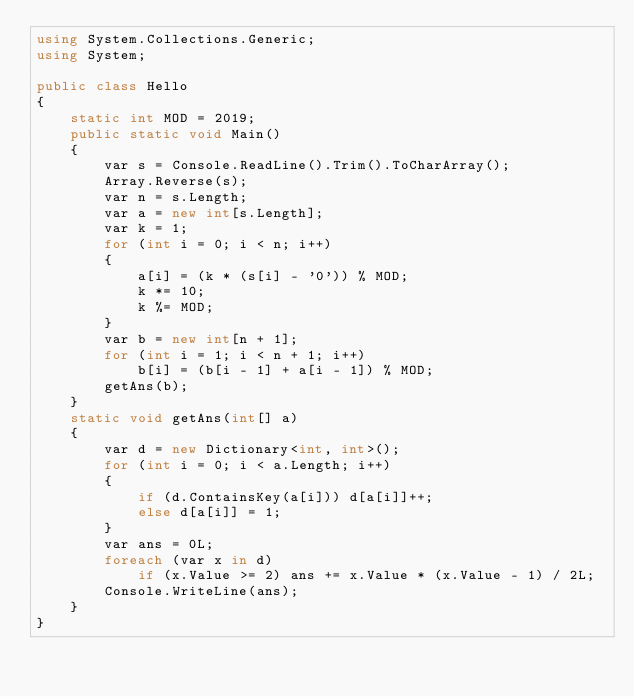Convert code to text. <code><loc_0><loc_0><loc_500><loc_500><_C#_>using System.Collections.Generic;
using System;

public class Hello
{
    static int MOD = 2019;
    public static void Main()
    {
        var s = Console.ReadLine().Trim().ToCharArray();
        Array.Reverse(s);
        var n = s.Length;
        var a = new int[s.Length];
        var k = 1;
        for (int i = 0; i < n; i++)
        {
            a[i] = (k * (s[i] - '0')) % MOD;
            k *= 10;
            k %= MOD;
        }
        var b = new int[n + 1];
        for (int i = 1; i < n + 1; i++)
            b[i] = (b[i - 1] + a[i - 1]) % MOD;
        getAns(b);
    }
    static void getAns(int[] a)
    {
        var d = new Dictionary<int, int>();
        for (int i = 0; i < a.Length; i++)
        {
            if (d.ContainsKey(a[i])) d[a[i]]++;
            else d[a[i]] = 1;
        }
        var ans = 0L;
        foreach (var x in d)
            if (x.Value >= 2) ans += x.Value * (x.Value - 1) / 2L;
        Console.WriteLine(ans);
    }
}
</code> 